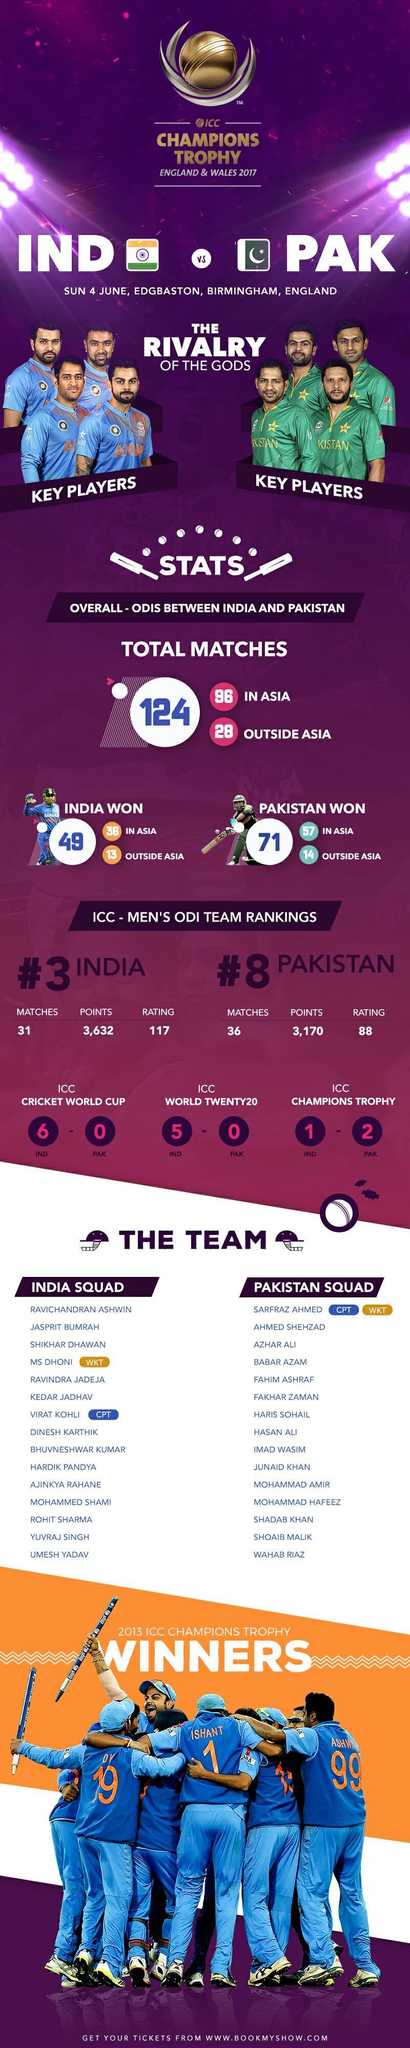who is the 8th one in the list of Pakistan team members?
Answer the question with a short phrase. Hasan Ali who is the third one in the list of Indian team members? MS Dhoni who is the second last in the list of Indian team members? Yuvraj Singh At which ground, more matches were played - in Asia or outside Asia? in Asia who is the third one in the list of Indian team members? Shikhar Dhawan who is the 5th one in the list of Pakistan team members? Fahim Ashraf 